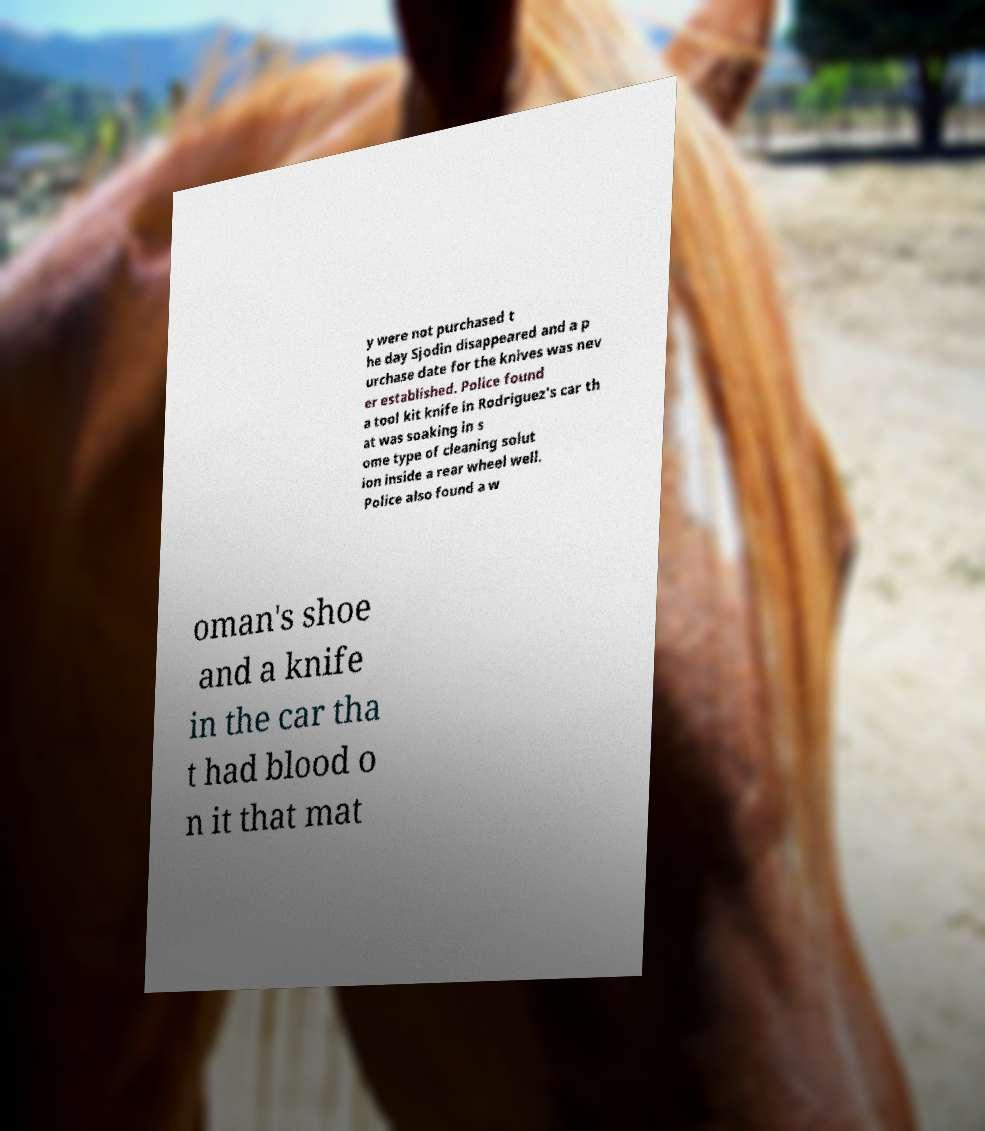There's text embedded in this image that I need extracted. Can you transcribe it verbatim? y were not purchased t he day Sjodin disappeared and a p urchase date for the knives was nev er established. Police found a tool kit knife in Rodriguez's car th at was soaking in s ome type of cleaning solut ion inside a rear wheel well. Police also found a w oman's shoe and a knife in the car tha t had blood o n it that mat 